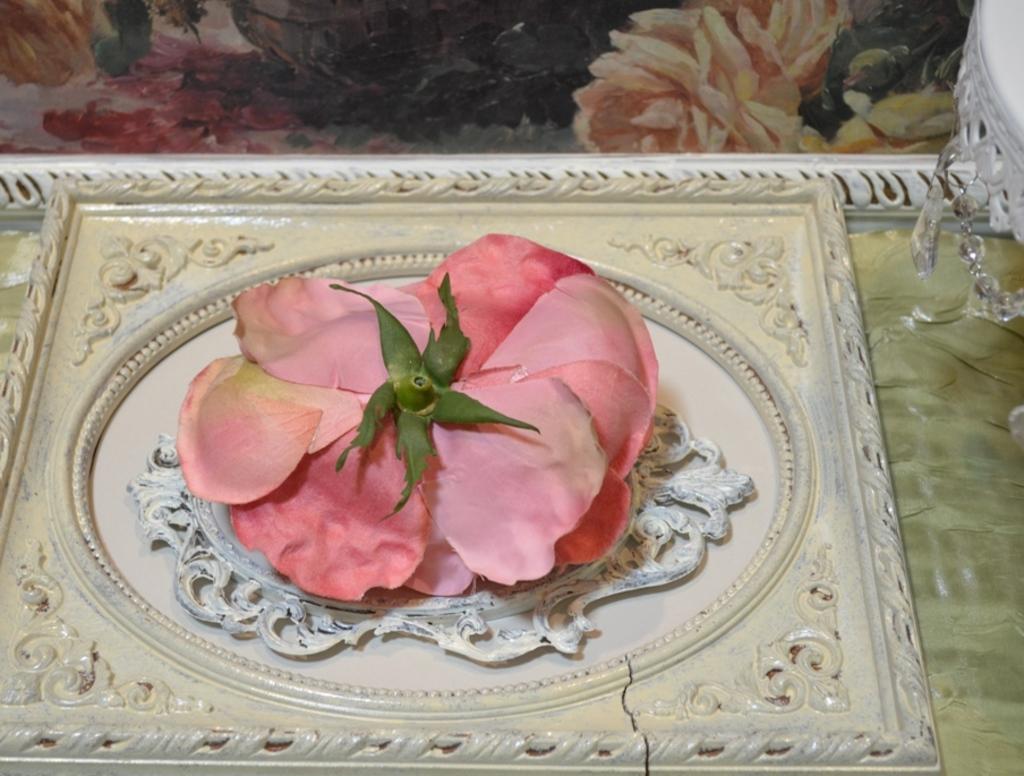How would you summarize this image in a sentence or two? In this image I can see a white colour thing and on it I can see a pink colour flower. On the top right side of this image I can see one more white colour thing and on the top side I can see a painting. 